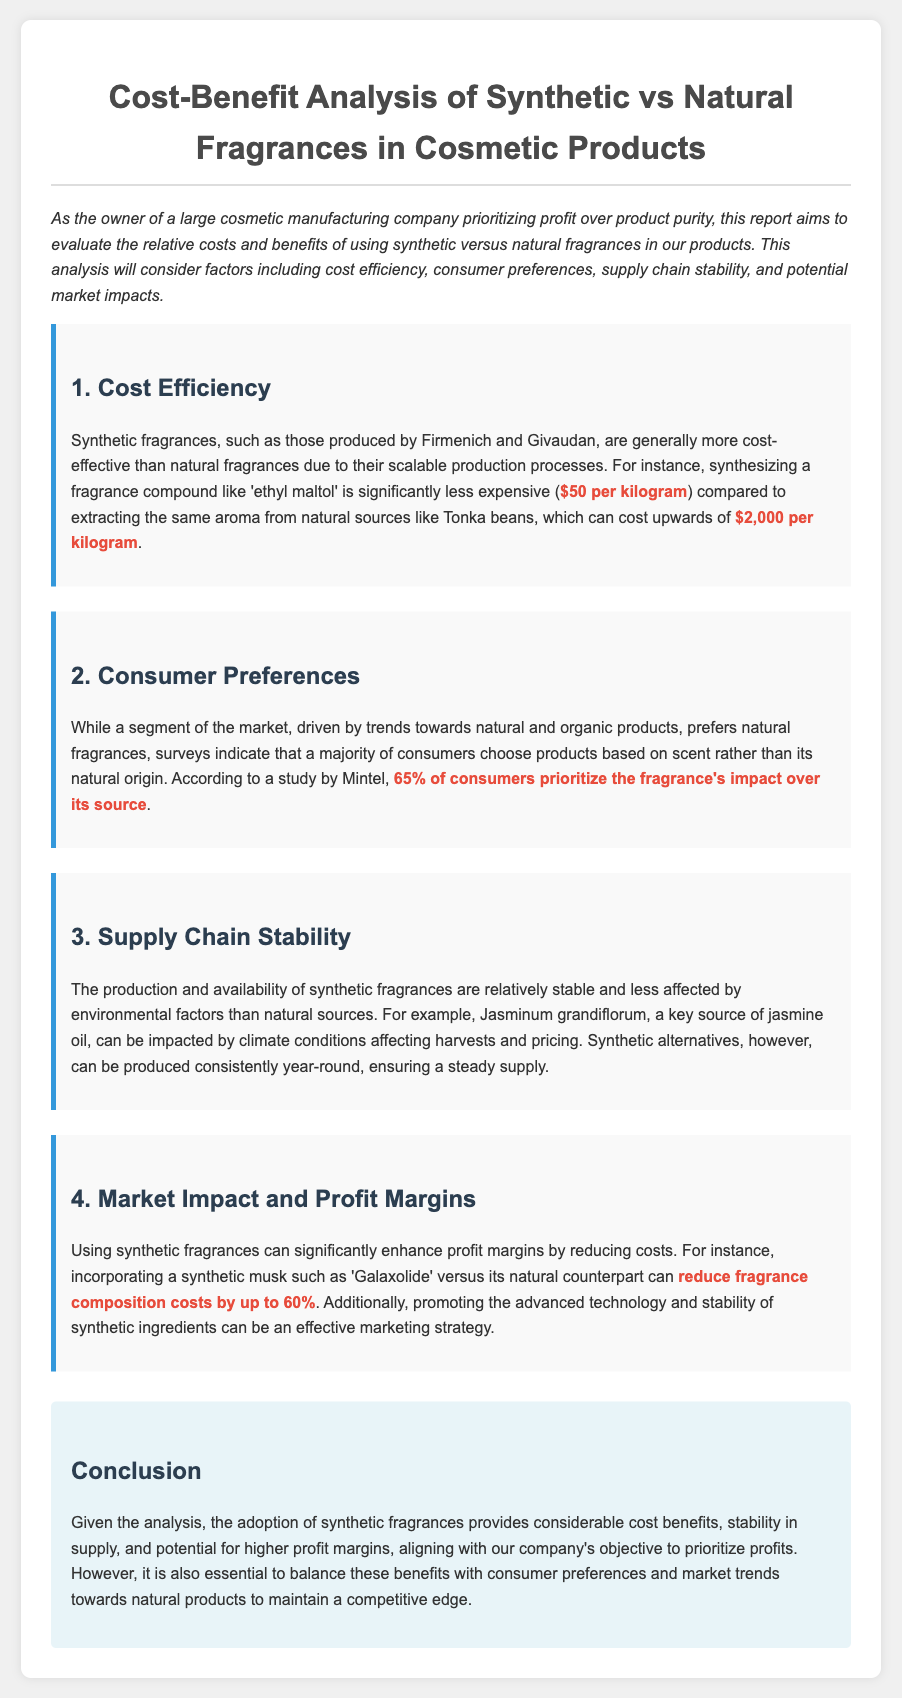what are the costs of synthetic fragrances per kilogram? The report states that synthesizing a fragrance compound like 'ethyl maltol' costs $50 per kilogram.
Answer: $50 per kilogram what are the costs of natural fragrances per kilogram? The document mentions that extracting aroma from natural sources like Tonka beans can cost upwards of $2,000 per kilogram.
Answer: $2,000 per kilogram what percentage of consumers prioritize fragrance's impact over its source? According to a study by Mintel cited in the report, 65% of consumers prioritize the fragrance's impact over its source.
Answer: 65% how much can fragrance composition costs be reduced by using synthetic alternatives? The report indicates that using synthetic musk such as 'Galaxolide' can reduce fragrance composition costs by up to 60%.
Answer: 60% why are synthetic fragrances more stable in supply? The document explains that synthetic fragrances can be produced consistently year-round, unlike natural sources which can be impacted by climate conditions.
Answer: Consistently year-round what is the main conclusion of the report? The conclusion summarizes that adopting synthetic fragrances provides considerable cost benefits, stability, and potential for higher profit margins.
Answer: Cost benefits and stability who are two companies mentioned as producers of synthetic fragrances? The report mentions Firmenich and Givaudan as producers of synthetic fragrances.
Answer: Firmenich and Givaudan what might be an effective marketing strategy for synthetic ingredients? The document suggests that promoting the advanced technology and stability of synthetic ingredients can be an effective marketing strategy.
Answer: Promoting advanced technology and stability what key factor does the report prioritize over product purity? The report is focused on evaluating costs and benefits, prioritizing profit alongside stability and market trends.
Answer: Profit 